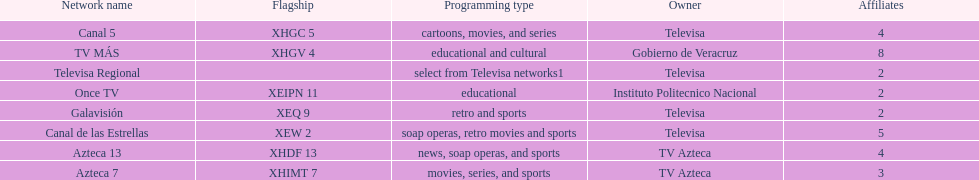How many networks have more affiliates than canal de las estrellas? 1. 